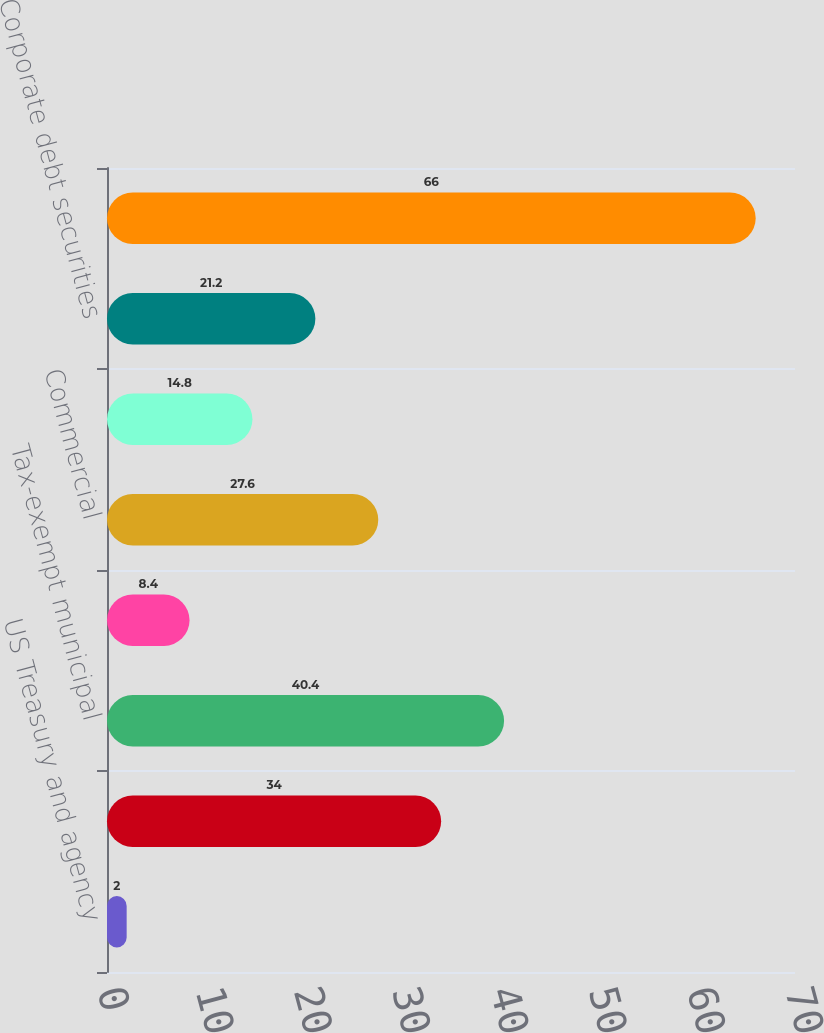Convert chart to OTSL. <chart><loc_0><loc_0><loc_500><loc_500><bar_chart><fcel>US Treasury and agency<fcel>Mortgage-backed securities<fcel>Tax-exempt municipal<fcel>Residential<fcel>Commercial<fcel>Asset-backed securities<fcel>Corporate debt securities<fcel>Total debt securities<nl><fcel>2<fcel>34<fcel>40.4<fcel>8.4<fcel>27.6<fcel>14.8<fcel>21.2<fcel>66<nl></chart> 